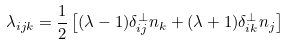Convert formula to latex. <formula><loc_0><loc_0><loc_500><loc_500>\lambda _ { i j k } = \frac { 1 } { 2 } \left [ ( \lambda - 1 ) \delta _ { i j } ^ { \perp } n _ { k } + ( \lambda + 1 ) \delta _ { i k } ^ { \perp } n _ { j } \right ]</formula> 